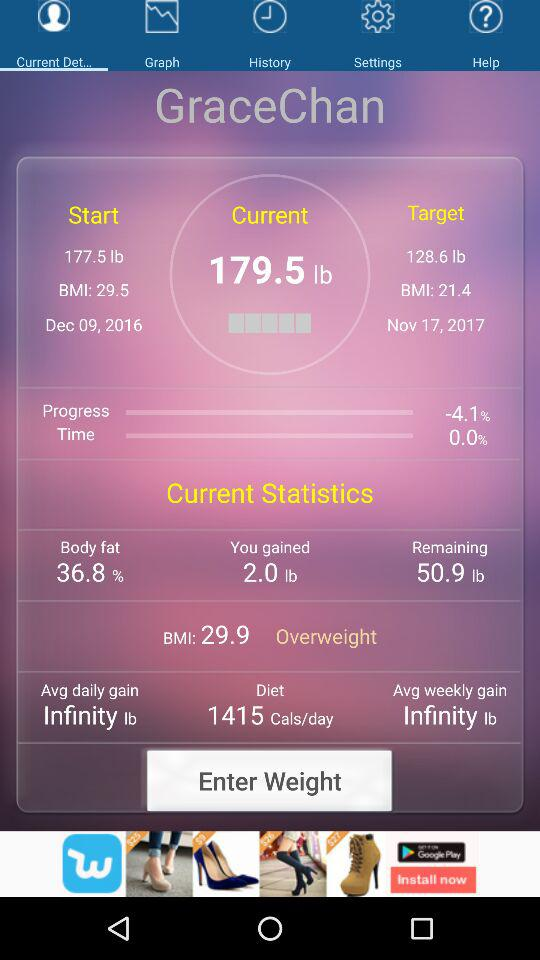Which tab is selected? The selected tab is "Current Det...". 